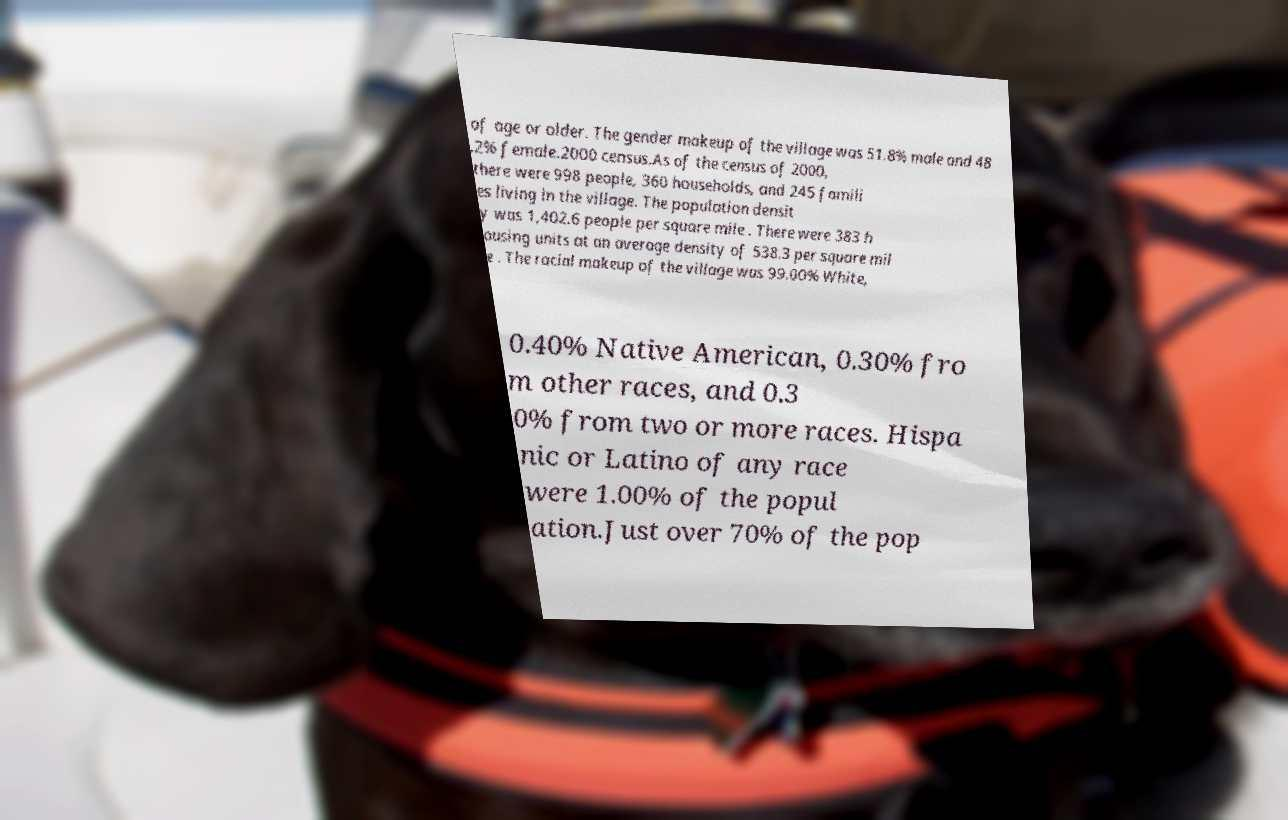There's text embedded in this image that I need extracted. Can you transcribe it verbatim? of age or older. The gender makeup of the village was 51.8% male and 48 .2% female.2000 census.As of the census of 2000, there were 998 people, 360 households, and 245 famili es living in the village. The population densit y was 1,402.6 people per square mile . There were 383 h ousing units at an average density of 538.3 per square mil e . The racial makeup of the village was 99.00% White, 0.40% Native American, 0.30% fro m other races, and 0.3 0% from two or more races. Hispa nic or Latino of any race were 1.00% of the popul ation.Just over 70% of the pop 